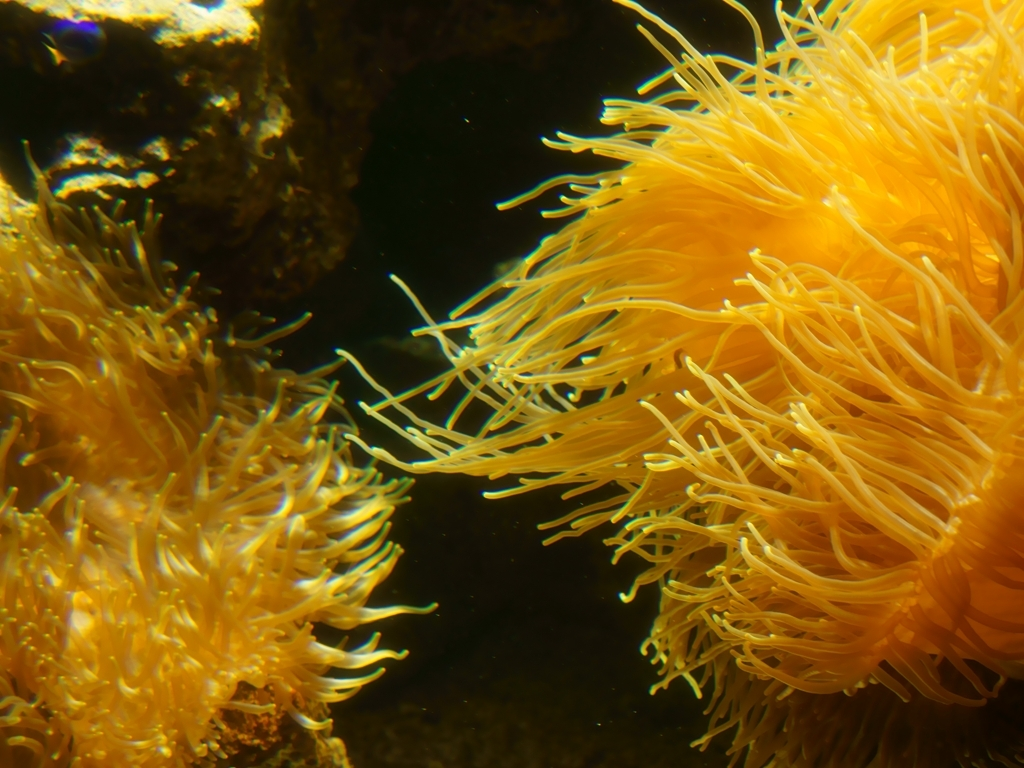How does this image contribute to our understanding of marine biodiversity? This image captures the beauty and complexity of marine life, highlighting the diversity of forms found in the ocean. Observing and documenting such biodiversity is crucial for scientific research, raising public awareness, and driving conservation efforts to protect these vital but often fragile ecosystems. 